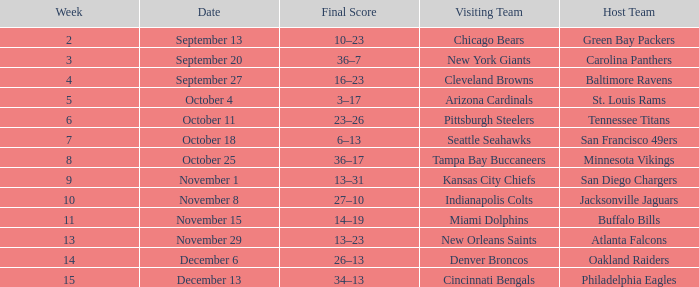When did the Baltimore Ravens play at home ? September 27. 